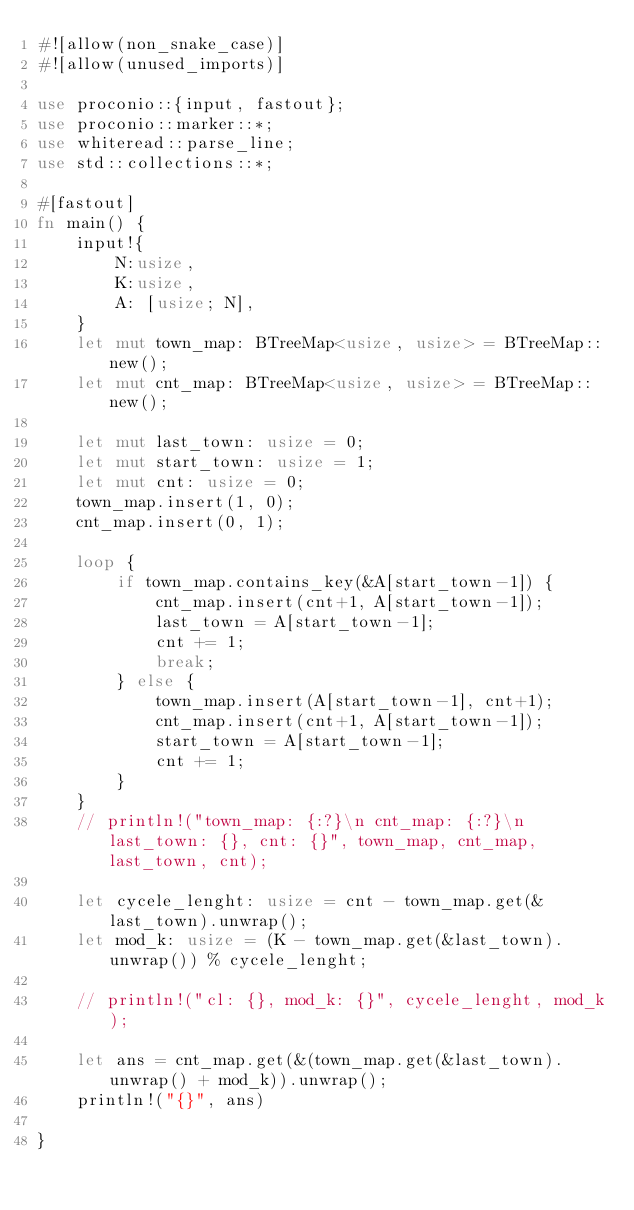Convert code to text. <code><loc_0><loc_0><loc_500><loc_500><_Rust_>#![allow(non_snake_case)]
#![allow(unused_imports)]
 
use proconio::{input, fastout};
use proconio::marker::*;
use whiteread::parse_line;
use std::collections::*;

#[fastout]
fn main() {
    input!{
        N:usize,
        K:usize,
        A: [usize; N],
    }
    let mut town_map: BTreeMap<usize, usize> = BTreeMap::new();
    let mut cnt_map: BTreeMap<usize, usize> = BTreeMap::new();
    
    let mut last_town: usize = 0;
    let mut start_town: usize = 1;
    let mut cnt: usize = 0;
    town_map.insert(1, 0);
    cnt_map.insert(0, 1);

    loop {
        if town_map.contains_key(&A[start_town-1]) {
            cnt_map.insert(cnt+1, A[start_town-1]);
            last_town = A[start_town-1];
            cnt += 1;
            break;
        } else {
            town_map.insert(A[start_town-1], cnt+1);
            cnt_map.insert(cnt+1, A[start_town-1]);
            start_town = A[start_town-1];
            cnt += 1;
        }
    }
    // println!("town_map: {:?}\n cnt_map: {:?}\n last_town: {}, cnt: {}", town_map, cnt_map, last_town, cnt);

    let cycele_lenght: usize = cnt - town_map.get(&last_town).unwrap();
    let mod_k: usize = (K - town_map.get(&last_town).unwrap()) % cycele_lenght;

    // println!("cl: {}, mod_k: {}", cycele_lenght, mod_k);

    let ans = cnt_map.get(&(town_map.get(&last_town).unwrap() + mod_k)).unwrap();
    println!("{}", ans)
    
}
</code> 